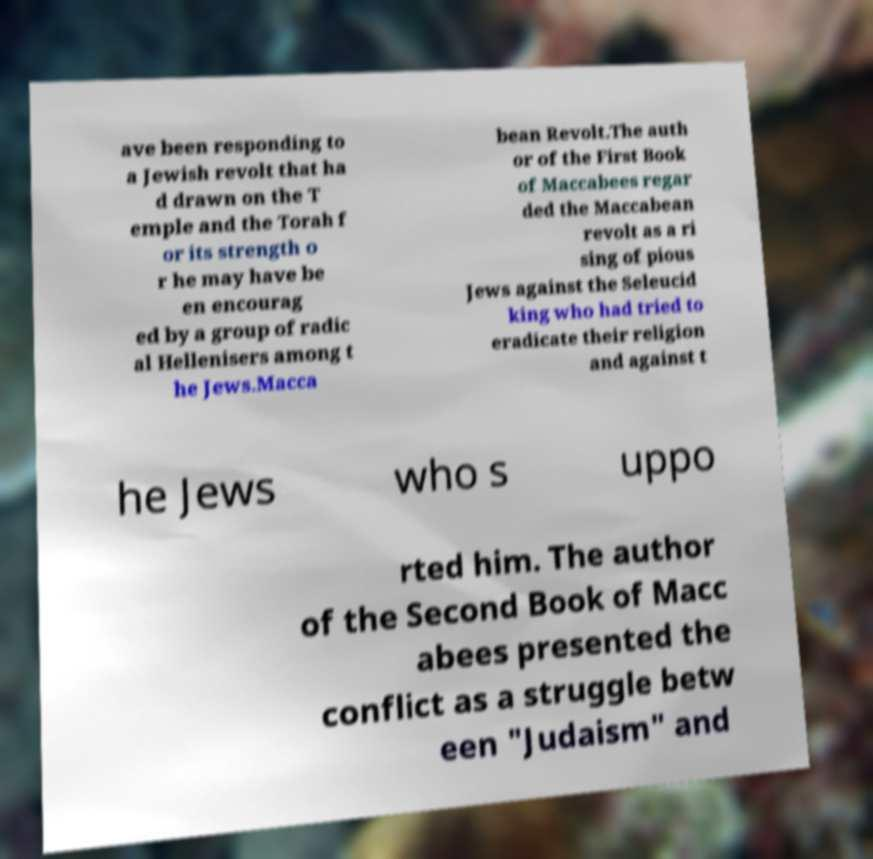Could you assist in decoding the text presented in this image and type it out clearly? ave been responding to a Jewish revolt that ha d drawn on the T emple and the Torah f or its strength o r he may have be en encourag ed by a group of radic al Hellenisers among t he Jews.Macca bean Revolt.The auth or of the First Book of Maccabees regar ded the Maccabean revolt as a ri sing of pious Jews against the Seleucid king who had tried to eradicate their religion and against t he Jews who s uppo rted him. The author of the Second Book of Macc abees presented the conflict as a struggle betw een "Judaism" and 